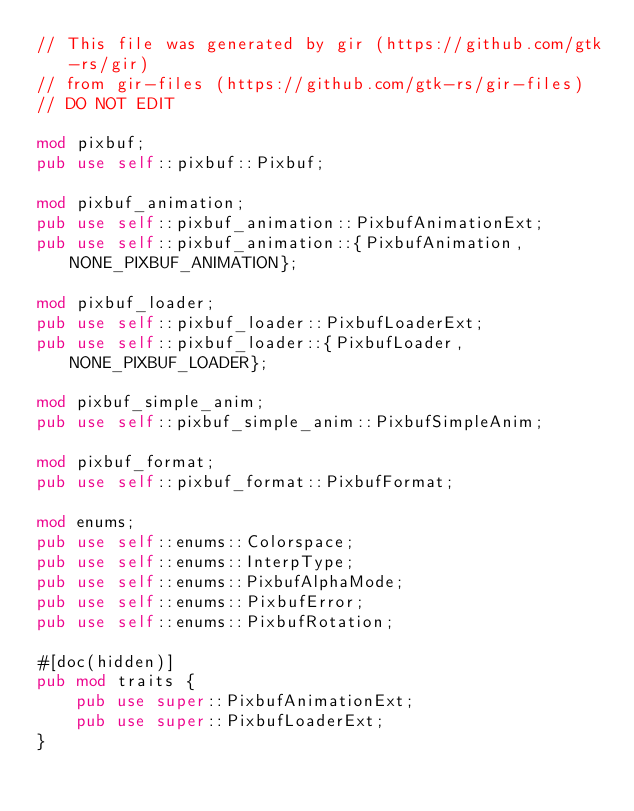<code> <loc_0><loc_0><loc_500><loc_500><_Rust_>// This file was generated by gir (https://github.com/gtk-rs/gir)
// from gir-files (https://github.com/gtk-rs/gir-files)
// DO NOT EDIT

mod pixbuf;
pub use self::pixbuf::Pixbuf;

mod pixbuf_animation;
pub use self::pixbuf_animation::PixbufAnimationExt;
pub use self::pixbuf_animation::{PixbufAnimation, NONE_PIXBUF_ANIMATION};

mod pixbuf_loader;
pub use self::pixbuf_loader::PixbufLoaderExt;
pub use self::pixbuf_loader::{PixbufLoader, NONE_PIXBUF_LOADER};

mod pixbuf_simple_anim;
pub use self::pixbuf_simple_anim::PixbufSimpleAnim;

mod pixbuf_format;
pub use self::pixbuf_format::PixbufFormat;

mod enums;
pub use self::enums::Colorspace;
pub use self::enums::InterpType;
pub use self::enums::PixbufAlphaMode;
pub use self::enums::PixbufError;
pub use self::enums::PixbufRotation;

#[doc(hidden)]
pub mod traits {
    pub use super::PixbufAnimationExt;
    pub use super::PixbufLoaderExt;
}
</code> 